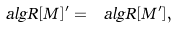<formula> <loc_0><loc_0><loc_500><loc_500>\ a l g { R } [ M ] ^ { \prime } = \ a l g { R } [ M ^ { \prime } ] ,</formula> 